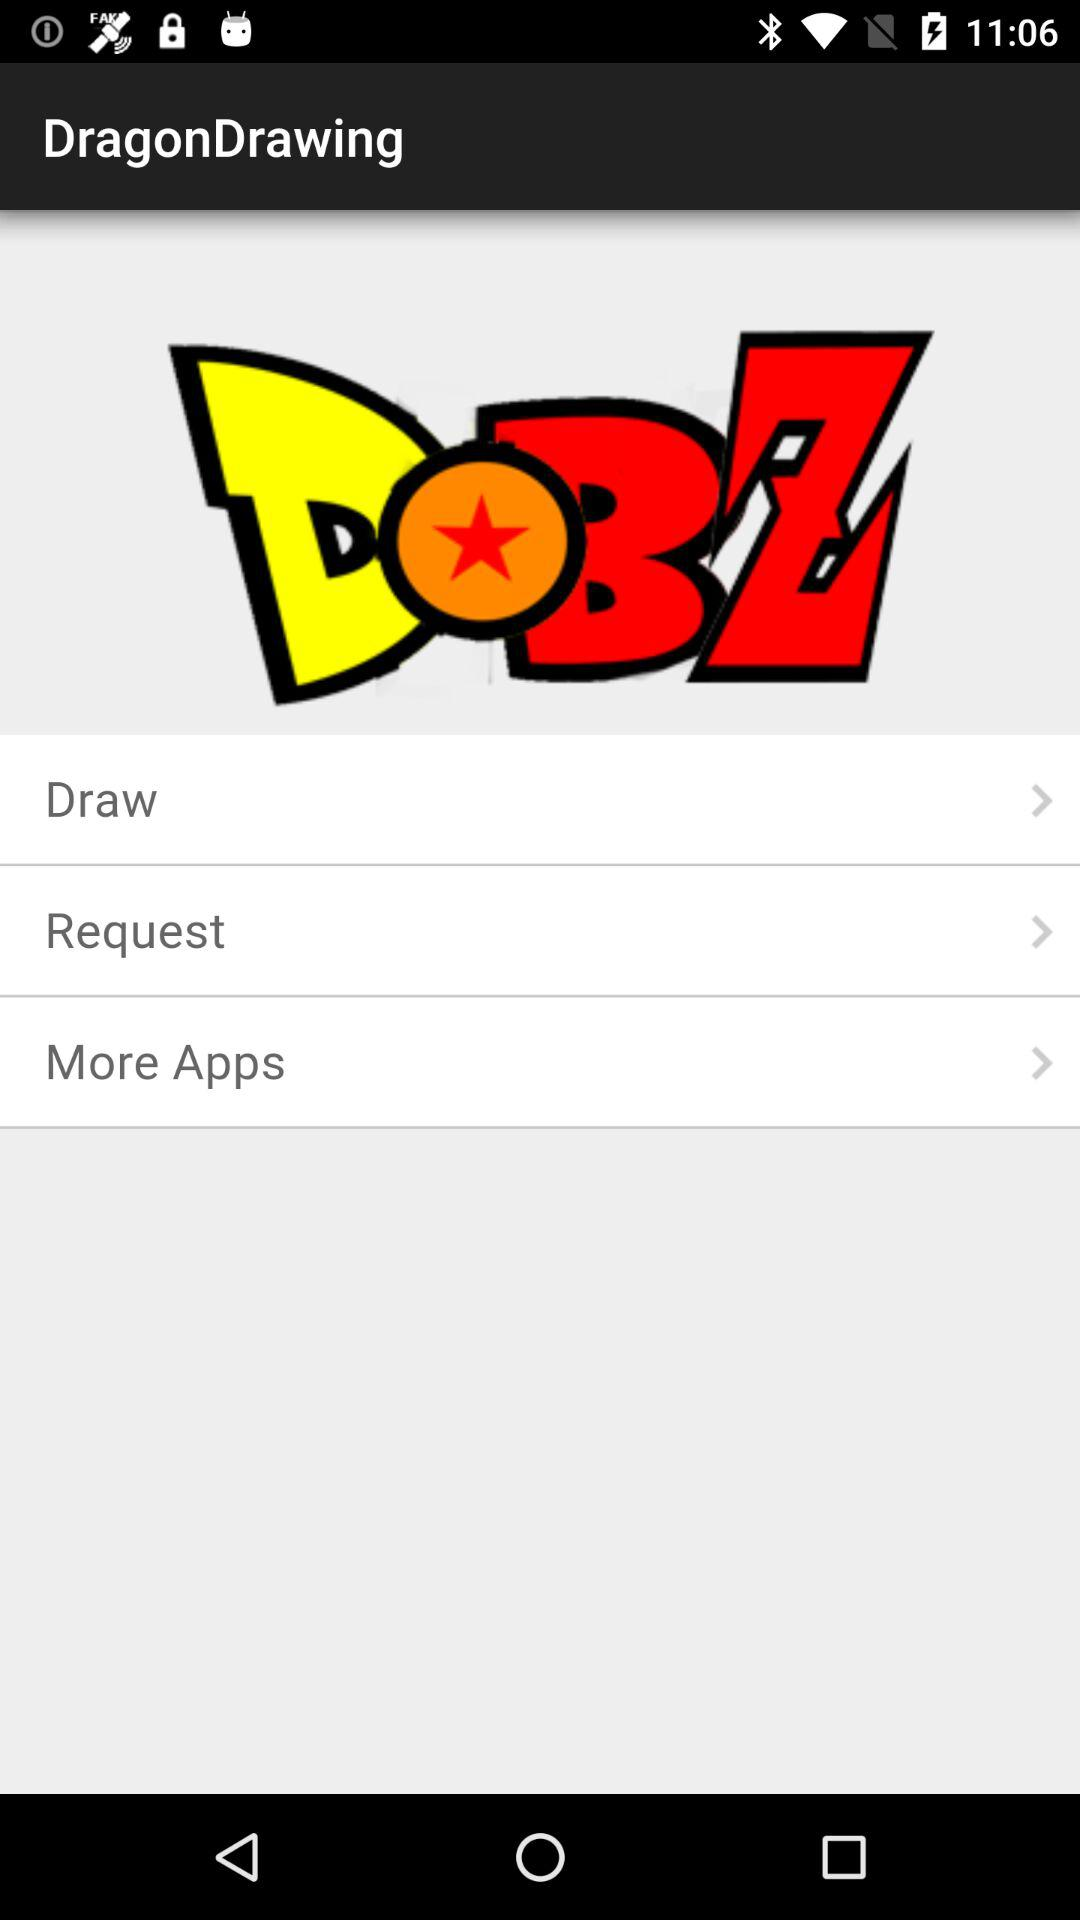What is the application name? The application name is "DragonDrawing". 